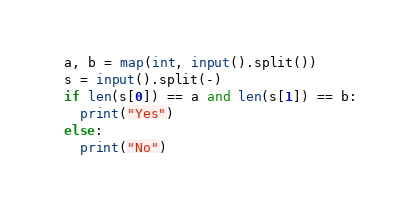Convert code to text. <code><loc_0><loc_0><loc_500><loc_500><_Python_>a, b = map(int, input().split())
s = input().split(-)
if len(s[0]) == a and len(s[1]) == b:
  print("Yes")
else:
  print("No")</code> 